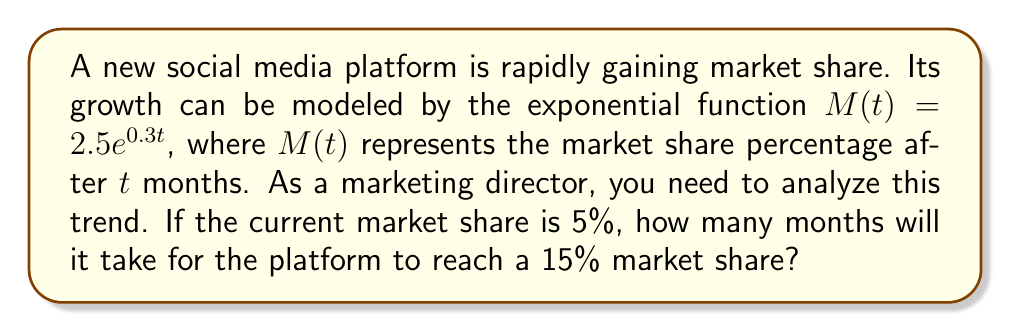Can you answer this question? Let's approach this step-by-step:

1) We're given the exponential growth model: $M(t) = 2.5e^{0.3t}$

2) We need to find $t$ when $M(t) = 15$. So, we set up the equation:

   $15 = 2.5e^{0.3t}$

3) Divide both sides by 2.5:

   $6 = e^{0.3t}$

4) Take the natural logarithm of both sides:

   $\ln(6) = \ln(e^{0.3t})$

5) Simplify the right side using the property of logarithms:

   $\ln(6) = 0.3t$

6) Divide both sides by 0.3:

   $\frac{\ln(6)}{0.3} = t$

7) Calculate the value:

   $t \approx 5.99$ months

8) Since we can't have a fraction of a month in this context, we round up to the nearest whole month.
Answer: 6 months 